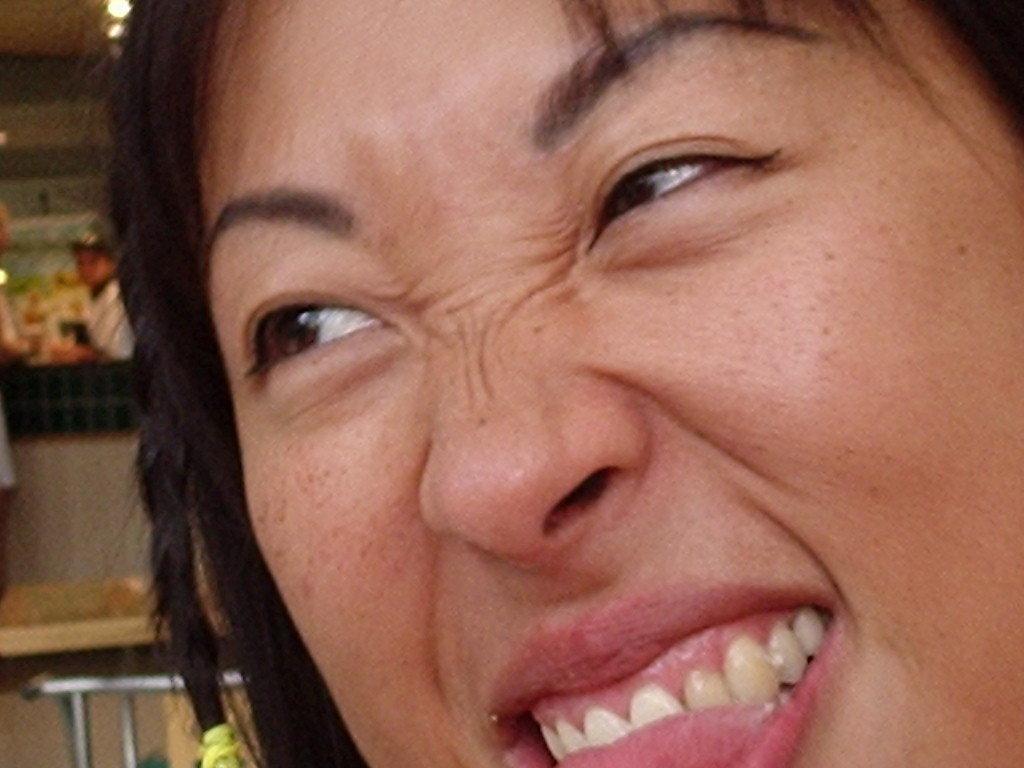Could you give a brief overview of what you see in this image? In the picture we can see a face of a woman giving some expression and behind her we can see a table and some things placed. 